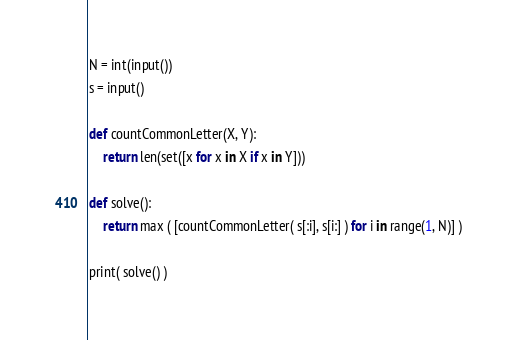Convert code to text. <code><loc_0><loc_0><loc_500><loc_500><_Python_>N = int(input())
s = input()

def countCommonLetter(X, Y):
    return len(set([x for x in X if x in Y]))

def solve():
    return max ( [countCommonLetter( s[:i], s[i:] ) for i in range(1, N)] )

print( solve() )
</code> 